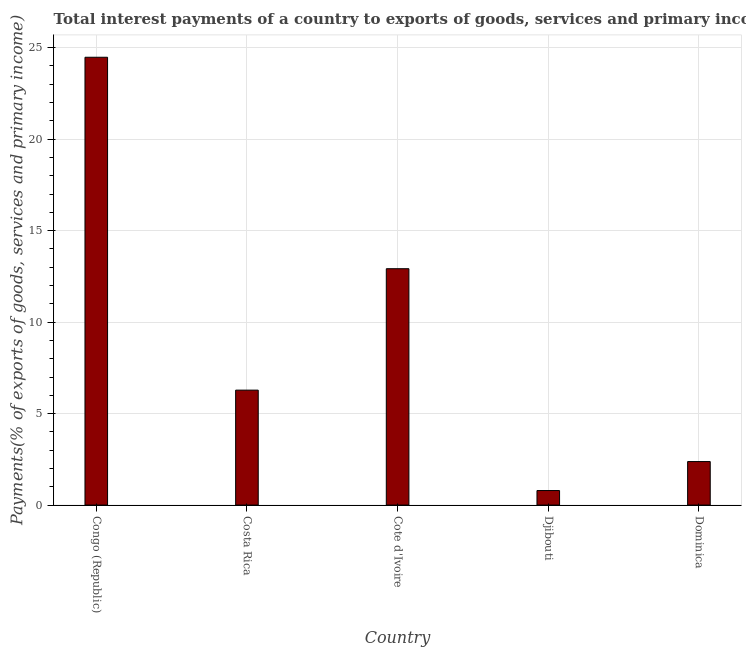What is the title of the graph?
Provide a short and direct response. Total interest payments of a country to exports of goods, services and primary income in 1994. What is the label or title of the Y-axis?
Offer a very short reply. Payments(% of exports of goods, services and primary income). What is the total interest payments on external debt in Djibouti?
Your answer should be compact. 0.79. Across all countries, what is the maximum total interest payments on external debt?
Offer a terse response. 24.48. Across all countries, what is the minimum total interest payments on external debt?
Give a very brief answer. 0.79. In which country was the total interest payments on external debt maximum?
Make the answer very short. Congo (Republic). In which country was the total interest payments on external debt minimum?
Offer a very short reply. Djibouti. What is the sum of the total interest payments on external debt?
Make the answer very short. 46.85. What is the difference between the total interest payments on external debt in Costa Rica and Cote d'Ivoire?
Your response must be concise. -6.64. What is the average total interest payments on external debt per country?
Provide a short and direct response. 9.37. What is the median total interest payments on external debt?
Your answer should be very brief. 6.28. In how many countries, is the total interest payments on external debt greater than 4 %?
Provide a succinct answer. 3. What is the ratio of the total interest payments on external debt in Djibouti to that in Dominica?
Your answer should be compact. 0.33. Is the total interest payments on external debt in Costa Rica less than that in Cote d'Ivoire?
Ensure brevity in your answer.  Yes. Is the difference between the total interest payments on external debt in Djibouti and Dominica greater than the difference between any two countries?
Offer a very short reply. No. What is the difference between the highest and the second highest total interest payments on external debt?
Give a very brief answer. 11.56. What is the difference between the highest and the lowest total interest payments on external debt?
Make the answer very short. 23.68. In how many countries, is the total interest payments on external debt greater than the average total interest payments on external debt taken over all countries?
Your response must be concise. 2. Are all the bars in the graph horizontal?
Your response must be concise. No. What is the difference between two consecutive major ticks on the Y-axis?
Your response must be concise. 5. Are the values on the major ticks of Y-axis written in scientific E-notation?
Ensure brevity in your answer.  No. What is the Payments(% of exports of goods, services and primary income) of Congo (Republic)?
Give a very brief answer. 24.48. What is the Payments(% of exports of goods, services and primary income) of Costa Rica?
Provide a short and direct response. 6.28. What is the Payments(% of exports of goods, services and primary income) of Cote d'Ivoire?
Ensure brevity in your answer.  12.92. What is the Payments(% of exports of goods, services and primary income) in Djibouti?
Keep it short and to the point. 0.79. What is the Payments(% of exports of goods, services and primary income) in Dominica?
Give a very brief answer. 2.38. What is the difference between the Payments(% of exports of goods, services and primary income) in Congo (Republic) and Costa Rica?
Provide a short and direct response. 18.19. What is the difference between the Payments(% of exports of goods, services and primary income) in Congo (Republic) and Cote d'Ivoire?
Provide a succinct answer. 11.56. What is the difference between the Payments(% of exports of goods, services and primary income) in Congo (Republic) and Djibouti?
Make the answer very short. 23.68. What is the difference between the Payments(% of exports of goods, services and primary income) in Congo (Republic) and Dominica?
Offer a terse response. 22.1. What is the difference between the Payments(% of exports of goods, services and primary income) in Costa Rica and Cote d'Ivoire?
Provide a succinct answer. -6.64. What is the difference between the Payments(% of exports of goods, services and primary income) in Costa Rica and Djibouti?
Make the answer very short. 5.49. What is the difference between the Payments(% of exports of goods, services and primary income) in Costa Rica and Dominica?
Your answer should be very brief. 3.9. What is the difference between the Payments(% of exports of goods, services and primary income) in Cote d'Ivoire and Djibouti?
Keep it short and to the point. 12.12. What is the difference between the Payments(% of exports of goods, services and primary income) in Cote d'Ivoire and Dominica?
Ensure brevity in your answer.  10.54. What is the difference between the Payments(% of exports of goods, services and primary income) in Djibouti and Dominica?
Give a very brief answer. -1.58. What is the ratio of the Payments(% of exports of goods, services and primary income) in Congo (Republic) to that in Costa Rica?
Provide a short and direct response. 3.9. What is the ratio of the Payments(% of exports of goods, services and primary income) in Congo (Republic) to that in Cote d'Ivoire?
Make the answer very short. 1.9. What is the ratio of the Payments(% of exports of goods, services and primary income) in Congo (Republic) to that in Djibouti?
Ensure brevity in your answer.  30.81. What is the ratio of the Payments(% of exports of goods, services and primary income) in Congo (Republic) to that in Dominica?
Provide a succinct answer. 10.29. What is the ratio of the Payments(% of exports of goods, services and primary income) in Costa Rica to that in Cote d'Ivoire?
Give a very brief answer. 0.49. What is the ratio of the Payments(% of exports of goods, services and primary income) in Costa Rica to that in Djibouti?
Your answer should be very brief. 7.91. What is the ratio of the Payments(% of exports of goods, services and primary income) in Costa Rica to that in Dominica?
Provide a succinct answer. 2.64. What is the ratio of the Payments(% of exports of goods, services and primary income) in Cote d'Ivoire to that in Djibouti?
Offer a very short reply. 16.26. What is the ratio of the Payments(% of exports of goods, services and primary income) in Cote d'Ivoire to that in Dominica?
Provide a succinct answer. 5.43. What is the ratio of the Payments(% of exports of goods, services and primary income) in Djibouti to that in Dominica?
Offer a terse response. 0.33. 